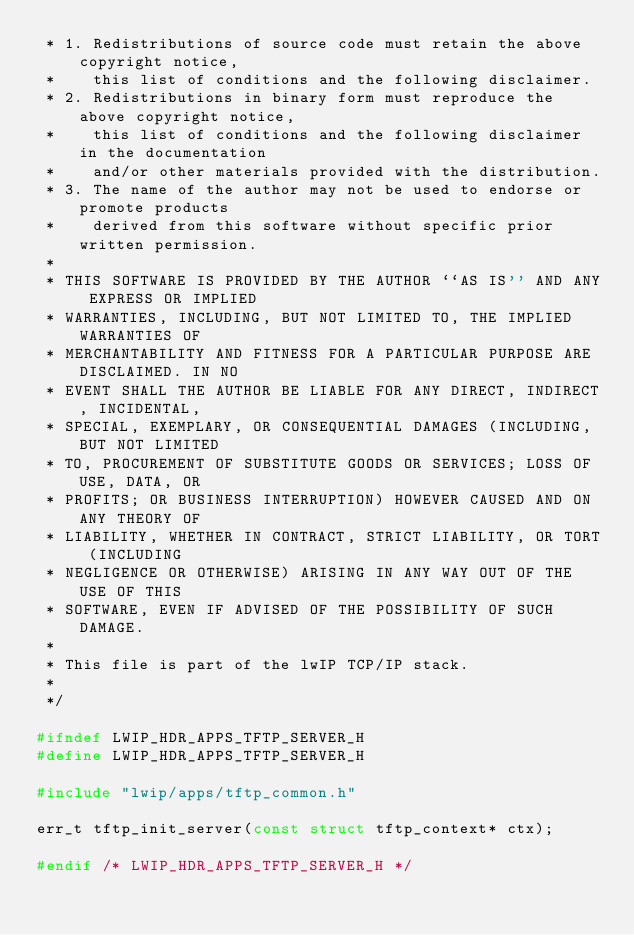Convert code to text. <code><loc_0><loc_0><loc_500><loc_500><_C_> * 1. Redistributions of source code must retain the above copyright notice,
 *    this list of conditions and the following disclaimer.
 * 2. Redistributions in binary form must reproduce the above copyright notice,
 *    this list of conditions and the following disclaimer in the documentation
 *    and/or other materials provided with the distribution.
 * 3. The name of the author may not be used to endorse or promote products
 *    derived from this software without specific prior written permission.
 *
 * THIS SOFTWARE IS PROVIDED BY THE AUTHOR ``AS IS'' AND ANY EXPRESS OR IMPLIED
 * WARRANTIES, INCLUDING, BUT NOT LIMITED TO, THE IMPLIED WARRANTIES OF
 * MERCHANTABILITY AND FITNESS FOR A PARTICULAR PURPOSE ARE DISCLAIMED. IN NO
 * EVENT SHALL THE AUTHOR BE LIABLE FOR ANY DIRECT, INDIRECT, INCIDENTAL,
 * SPECIAL, EXEMPLARY, OR CONSEQUENTIAL DAMAGES (INCLUDING, BUT NOT LIMITED
 * TO, PROCUREMENT OF SUBSTITUTE GOODS OR SERVICES; LOSS OF USE, DATA, OR
 * PROFITS; OR BUSINESS INTERRUPTION) HOWEVER CAUSED AND ON ANY THEORY OF
 * LIABILITY, WHETHER IN CONTRACT, STRICT LIABILITY, OR TORT (INCLUDING
 * NEGLIGENCE OR OTHERWISE) ARISING IN ANY WAY OUT OF THE USE OF THIS
 * SOFTWARE, EVEN IF ADVISED OF THE POSSIBILITY OF SUCH DAMAGE.
 *
 * This file is part of the lwIP TCP/IP stack.
 *
 */

#ifndef LWIP_HDR_APPS_TFTP_SERVER_H
#define LWIP_HDR_APPS_TFTP_SERVER_H

#include "lwip/apps/tftp_common.h"

err_t tftp_init_server(const struct tftp_context* ctx);

#endif /* LWIP_HDR_APPS_TFTP_SERVER_H */
</code> 